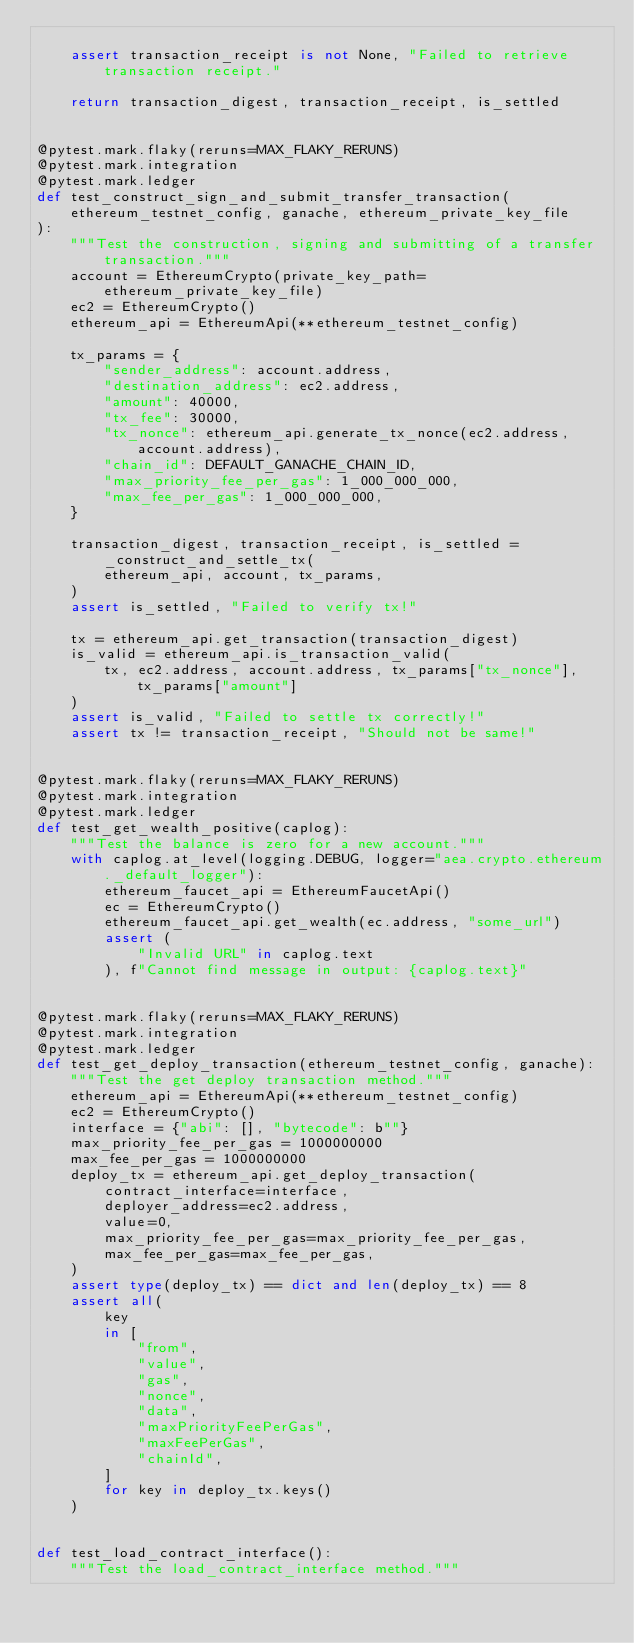<code> <loc_0><loc_0><loc_500><loc_500><_Python_>
    assert transaction_receipt is not None, "Failed to retrieve transaction receipt."

    return transaction_digest, transaction_receipt, is_settled


@pytest.mark.flaky(reruns=MAX_FLAKY_RERUNS)
@pytest.mark.integration
@pytest.mark.ledger
def test_construct_sign_and_submit_transfer_transaction(
    ethereum_testnet_config, ganache, ethereum_private_key_file
):
    """Test the construction, signing and submitting of a transfer transaction."""
    account = EthereumCrypto(private_key_path=ethereum_private_key_file)
    ec2 = EthereumCrypto()
    ethereum_api = EthereumApi(**ethereum_testnet_config)

    tx_params = {
        "sender_address": account.address,
        "destination_address": ec2.address,
        "amount": 40000,
        "tx_fee": 30000,
        "tx_nonce": ethereum_api.generate_tx_nonce(ec2.address, account.address),
        "chain_id": DEFAULT_GANACHE_CHAIN_ID,
        "max_priority_fee_per_gas": 1_000_000_000,
        "max_fee_per_gas": 1_000_000_000,
    }

    transaction_digest, transaction_receipt, is_settled = _construct_and_settle_tx(
        ethereum_api, account, tx_params,
    )
    assert is_settled, "Failed to verify tx!"

    tx = ethereum_api.get_transaction(transaction_digest)
    is_valid = ethereum_api.is_transaction_valid(
        tx, ec2.address, account.address, tx_params["tx_nonce"], tx_params["amount"]
    )
    assert is_valid, "Failed to settle tx correctly!"
    assert tx != transaction_receipt, "Should not be same!"


@pytest.mark.flaky(reruns=MAX_FLAKY_RERUNS)
@pytest.mark.integration
@pytest.mark.ledger
def test_get_wealth_positive(caplog):
    """Test the balance is zero for a new account."""
    with caplog.at_level(logging.DEBUG, logger="aea.crypto.ethereum._default_logger"):
        ethereum_faucet_api = EthereumFaucetApi()
        ec = EthereumCrypto()
        ethereum_faucet_api.get_wealth(ec.address, "some_url")
        assert (
            "Invalid URL" in caplog.text
        ), f"Cannot find message in output: {caplog.text}"


@pytest.mark.flaky(reruns=MAX_FLAKY_RERUNS)
@pytest.mark.integration
@pytest.mark.ledger
def test_get_deploy_transaction(ethereum_testnet_config, ganache):
    """Test the get deploy transaction method."""
    ethereum_api = EthereumApi(**ethereum_testnet_config)
    ec2 = EthereumCrypto()
    interface = {"abi": [], "bytecode": b""}
    max_priority_fee_per_gas = 1000000000
    max_fee_per_gas = 1000000000
    deploy_tx = ethereum_api.get_deploy_transaction(
        contract_interface=interface,
        deployer_address=ec2.address,
        value=0,
        max_priority_fee_per_gas=max_priority_fee_per_gas,
        max_fee_per_gas=max_fee_per_gas,
    )
    assert type(deploy_tx) == dict and len(deploy_tx) == 8
    assert all(
        key
        in [
            "from",
            "value",
            "gas",
            "nonce",
            "data",
            "maxPriorityFeePerGas",
            "maxFeePerGas",
            "chainId",
        ]
        for key in deploy_tx.keys()
    )


def test_load_contract_interface():
    """Test the load_contract_interface method."""</code> 